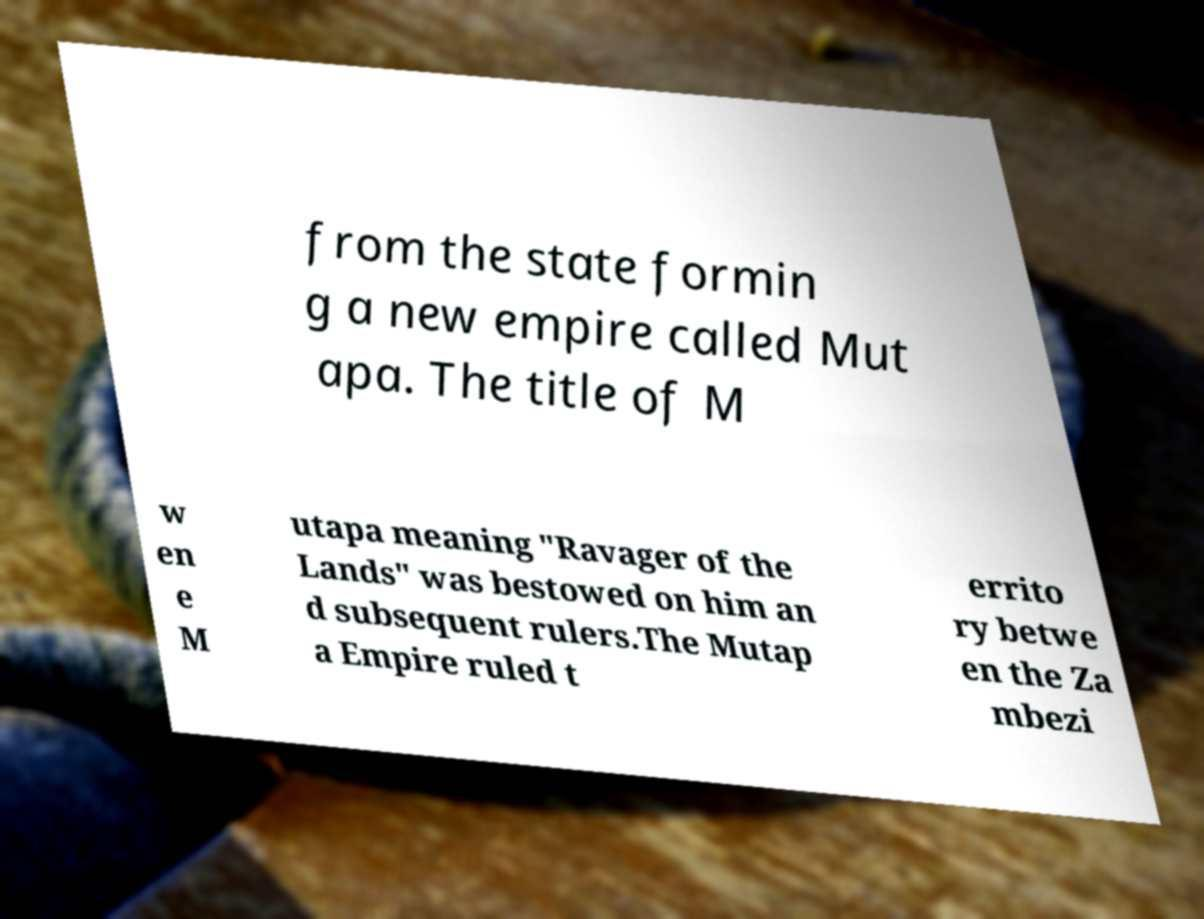Can you read and provide the text displayed in the image?This photo seems to have some interesting text. Can you extract and type it out for me? from the state formin g a new empire called Mut apa. The title of M w en e M utapa meaning "Ravager of the Lands" was bestowed on him an d subsequent rulers.The Mutap a Empire ruled t errito ry betwe en the Za mbezi 